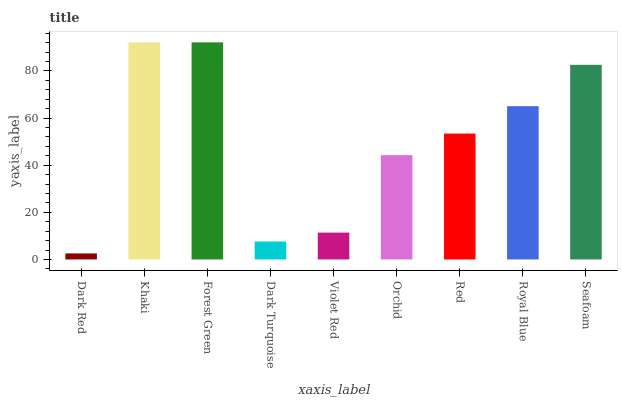Is Dark Red the minimum?
Answer yes or no. Yes. Is Forest Green the maximum?
Answer yes or no. Yes. Is Khaki the minimum?
Answer yes or no. No. Is Khaki the maximum?
Answer yes or no. No. Is Khaki greater than Dark Red?
Answer yes or no. Yes. Is Dark Red less than Khaki?
Answer yes or no. Yes. Is Dark Red greater than Khaki?
Answer yes or no. No. Is Khaki less than Dark Red?
Answer yes or no. No. Is Red the high median?
Answer yes or no. Yes. Is Red the low median?
Answer yes or no. Yes. Is Seafoam the high median?
Answer yes or no. No. Is Violet Red the low median?
Answer yes or no. No. 